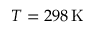Convert formula to latex. <formula><loc_0><loc_0><loc_500><loc_500>T = 2 9 8 \, K</formula> 